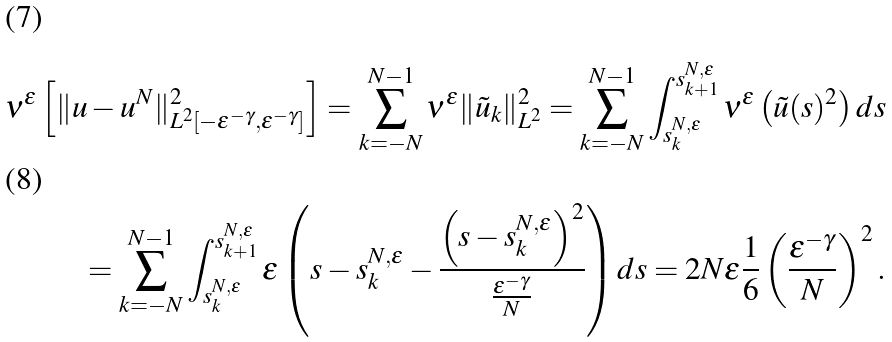<formula> <loc_0><loc_0><loc_500><loc_500>\nu ^ { \varepsilon } \left [ \| u - u ^ { N } \| _ { L ^ { 2 } [ - \varepsilon ^ { - \gamma } , \varepsilon ^ { - \gamma } ] } ^ { 2 } \right ] = \sum _ { k = - N } ^ { N - 1 } \nu ^ { \varepsilon } \| \tilde { u } _ { k } \| _ { L ^ { 2 } } ^ { 2 } = \sum _ { k = - N } ^ { N - 1 } \int _ { s _ { k } ^ { N , \varepsilon } } ^ { s _ { k + 1 } ^ { N , \varepsilon } } \nu ^ { \varepsilon } \left ( \tilde { u } ( s ) ^ { 2 } \right ) d s \\ = \sum _ { k = - N } ^ { N - 1 } \int _ { s _ { k } ^ { N , \varepsilon } } ^ { s _ { k + 1 } ^ { N , \varepsilon } } \varepsilon \left ( s - s _ { k } ^ { N , \varepsilon } - \frac { \left ( s - s _ { k } ^ { N , \varepsilon } \right ) ^ { 2 } } { \frac { \varepsilon ^ { - \gamma } } { N } } \right ) d s = 2 N \varepsilon \frac { 1 } { 6 } \left ( \frac { \varepsilon ^ { - \gamma } } { N } \right ) ^ { 2 } .</formula> 